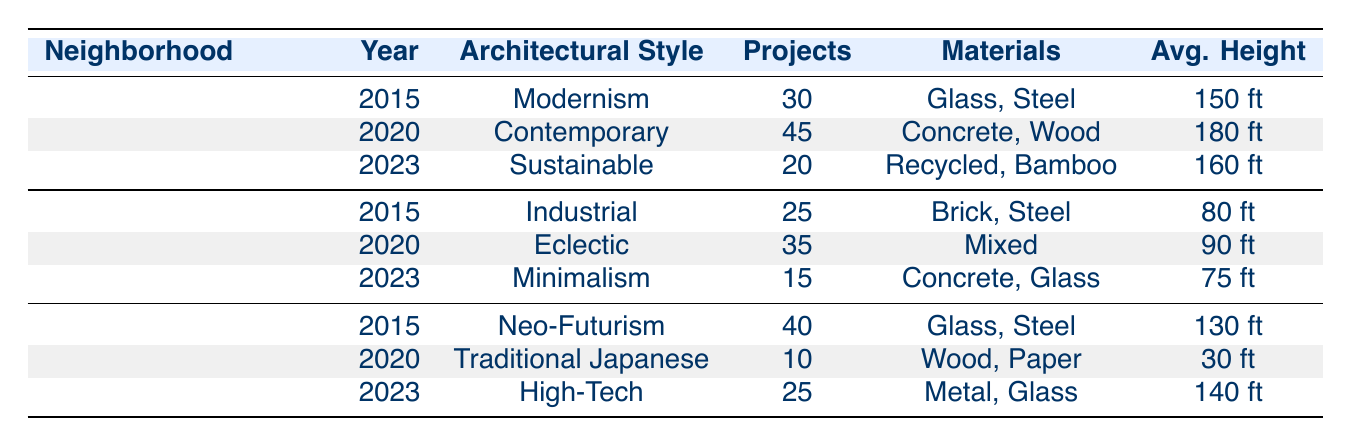What architectural style was adopted in Downtown Seattle in 2020? The table indicates that in Downtown Seattle in 2020, the architectural style was Contemporary.
Answer: Contemporary Which neighborhood had the highest number of construction projects in 2015? In 2015, Downtown Seattle had 30 projects, Williamsburg had 25, and Shibuya had 40 projects. Shibuya had the highest number with 40 projects.
Answer: Shibuya, Tokyo How many projects were there in Williamsburg, Brooklyn in 2023? The table shows that Williamsburg, Brooklyn had 15 projects in 2023.
Answer: 15 What is the average height of structures in Shibuya, Tokyo for all recorded years? To calculate the average height: (130 + 30 + 140) / 3 = 100 ft. Therefore, the average height is 100 ft.
Answer: 100 ft Has the predominant architectural style in Downtown Seattle changed from 2015 to 2023? Yes, in 2015 the style was Modernism, in 2020 it was Contemporary, and in 2023 it was Sustainable, indicating a change in style over the years.
Answer: Yes What is the difference in the number of projects between 2020 and 2023 in Williamsburg, Brooklyn? In 2020 there were 35 projects and in 2023 there were 15. The difference is 35 - 15 = 20 projects.
Answer: 20 projects Which architectural style had the least number of projects in the Shibuya, Tokyo neighborhood over the years? The Traditional Japanese style in 2020 had only 10 projects, which is less than the other styles recorded in Shibuya.
Answer: Traditional Japanese What was the predominant material in the Sustainable architectural style for Downtown Seattle in 2023? The table specifies that the predominant materials for the Sustainable style were Recycled Materials and Bamboo.
Answer: Recycled Materials, Bamboo 